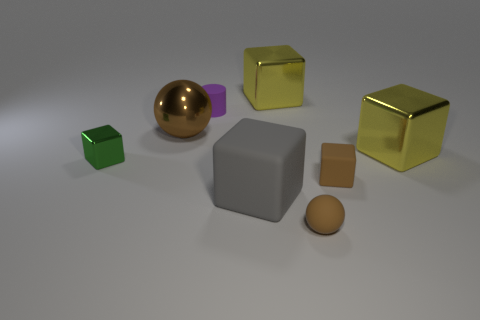How many objects are there, and can you name their shapes? There are six objects in the image: a green cube, a purple cube, a gold cube, a gray cube, a spherical gold object, and a brown cylinder. 